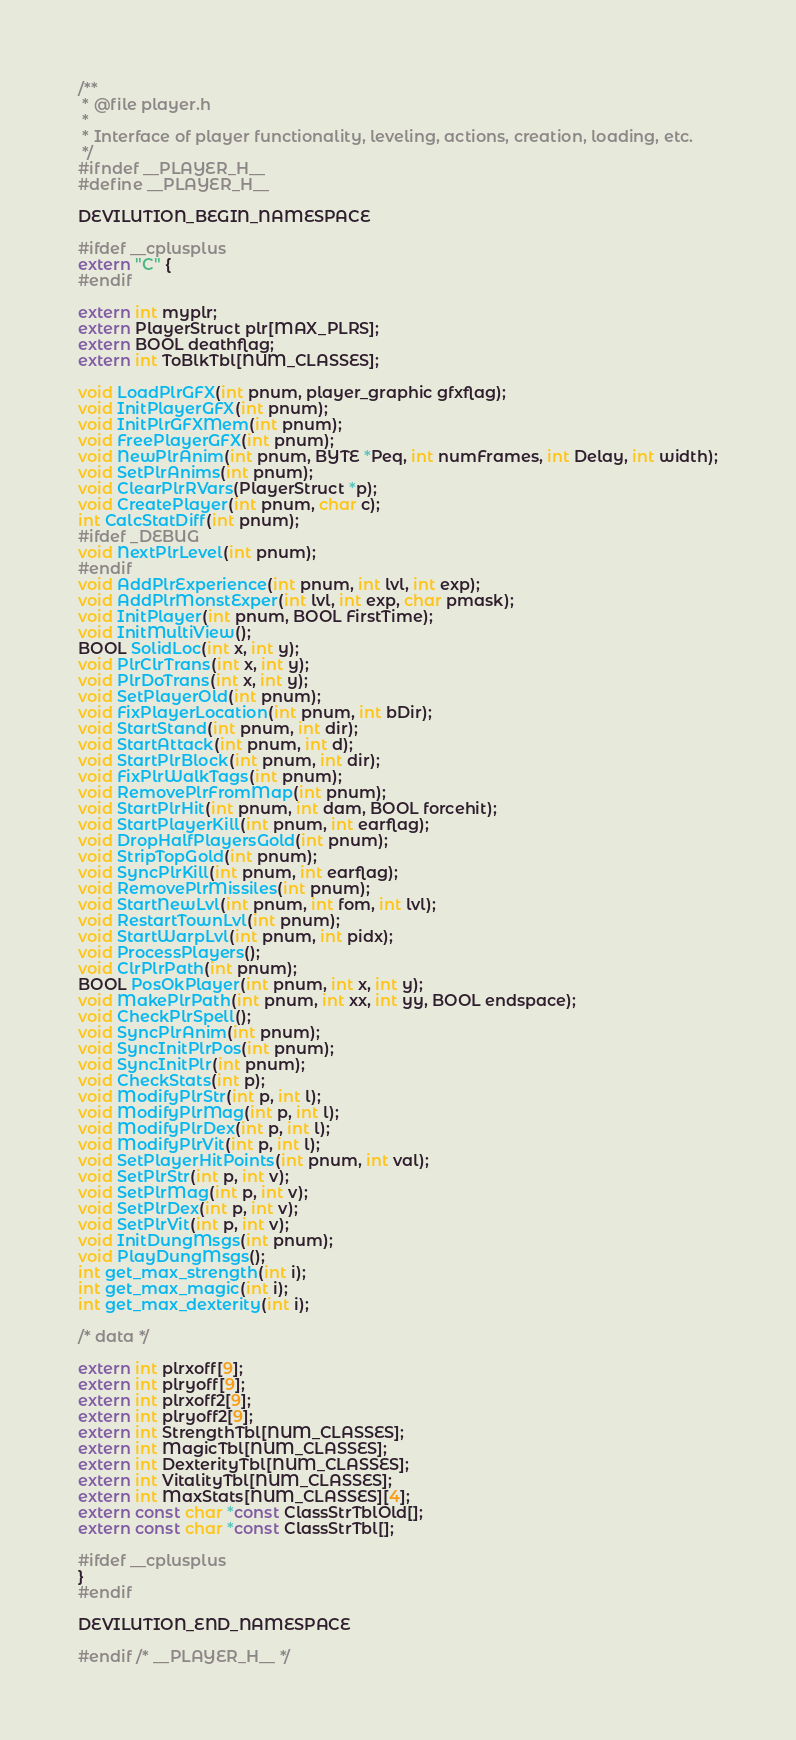<code> <loc_0><loc_0><loc_500><loc_500><_C_>/**
 * @file player.h
 *
 * Interface of player functionality, leveling, actions, creation, loading, etc.
 */
#ifndef __PLAYER_H__
#define __PLAYER_H__

DEVILUTION_BEGIN_NAMESPACE

#ifdef __cplusplus
extern "C" {
#endif

extern int myplr;
extern PlayerStruct plr[MAX_PLRS];
extern BOOL deathflag;
extern int ToBlkTbl[NUM_CLASSES];

void LoadPlrGFX(int pnum, player_graphic gfxflag);
void InitPlayerGFX(int pnum);
void InitPlrGFXMem(int pnum);
void FreePlayerGFX(int pnum);
void NewPlrAnim(int pnum, BYTE *Peq, int numFrames, int Delay, int width);
void SetPlrAnims(int pnum);
void ClearPlrRVars(PlayerStruct *p);
void CreatePlayer(int pnum, char c);
int CalcStatDiff(int pnum);
#ifdef _DEBUG
void NextPlrLevel(int pnum);
#endif
void AddPlrExperience(int pnum, int lvl, int exp);
void AddPlrMonstExper(int lvl, int exp, char pmask);
void InitPlayer(int pnum, BOOL FirstTime);
void InitMultiView();
BOOL SolidLoc(int x, int y);
void PlrClrTrans(int x, int y);
void PlrDoTrans(int x, int y);
void SetPlayerOld(int pnum);
void FixPlayerLocation(int pnum, int bDir);
void StartStand(int pnum, int dir);
void StartAttack(int pnum, int d);
void StartPlrBlock(int pnum, int dir);
void FixPlrWalkTags(int pnum);
void RemovePlrFromMap(int pnum);
void StartPlrHit(int pnum, int dam, BOOL forcehit);
void StartPlayerKill(int pnum, int earflag);
void DropHalfPlayersGold(int pnum);
void StripTopGold(int pnum);
void SyncPlrKill(int pnum, int earflag);
void RemovePlrMissiles(int pnum);
void StartNewLvl(int pnum, int fom, int lvl);
void RestartTownLvl(int pnum);
void StartWarpLvl(int pnum, int pidx);
void ProcessPlayers();
void ClrPlrPath(int pnum);
BOOL PosOkPlayer(int pnum, int x, int y);
void MakePlrPath(int pnum, int xx, int yy, BOOL endspace);
void CheckPlrSpell();
void SyncPlrAnim(int pnum);
void SyncInitPlrPos(int pnum);
void SyncInitPlr(int pnum);
void CheckStats(int p);
void ModifyPlrStr(int p, int l);
void ModifyPlrMag(int p, int l);
void ModifyPlrDex(int p, int l);
void ModifyPlrVit(int p, int l);
void SetPlayerHitPoints(int pnum, int val);
void SetPlrStr(int p, int v);
void SetPlrMag(int p, int v);
void SetPlrDex(int p, int v);
void SetPlrVit(int p, int v);
void InitDungMsgs(int pnum);
void PlayDungMsgs();
int get_max_strength(int i);
int get_max_magic(int i);
int get_max_dexterity(int i);

/* data */

extern int plrxoff[9];
extern int plryoff[9];
extern int plrxoff2[9];
extern int plryoff2[9];
extern int StrengthTbl[NUM_CLASSES];
extern int MagicTbl[NUM_CLASSES];
extern int DexterityTbl[NUM_CLASSES];
extern int VitalityTbl[NUM_CLASSES];
extern int MaxStats[NUM_CLASSES][4];
extern const char *const ClassStrTblOld[];
extern const char *const ClassStrTbl[];

#ifdef __cplusplus
}
#endif

DEVILUTION_END_NAMESPACE

#endif /* __PLAYER_H__ */
</code> 